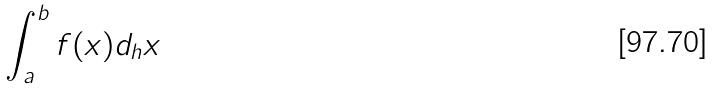<formula> <loc_0><loc_0><loc_500><loc_500>\int _ { a } ^ { b } f ( x ) d _ { h } x</formula> 